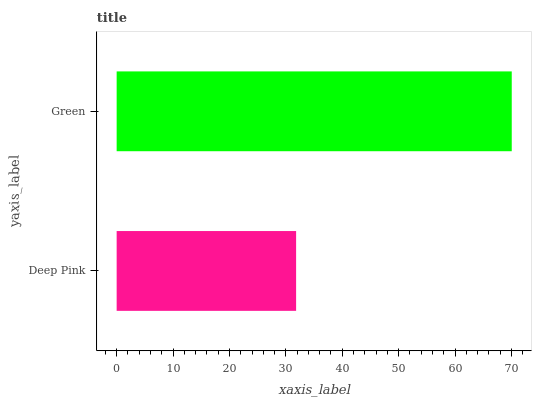Is Deep Pink the minimum?
Answer yes or no. Yes. Is Green the maximum?
Answer yes or no. Yes. Is Green the minimum?
Answer yes or no. No. Is Green greater than Deep Pink?
Answer yes or no. Yes. Is Deep Pink less than Green?
Answer yes or no. Yes. Is Deep Pink greater than Green?
Answer yes or no. No. Is Green less than Deep Pink?
Answer yes or no. No. Is Green the high median?
Answer yes or no. Yes. Is Deep Pink the low median?
Answer yes or no. Yes. Is Deep Pink the high median?
Answer yes or no. No. Is Green the low median?
Answer yes or no. No. 